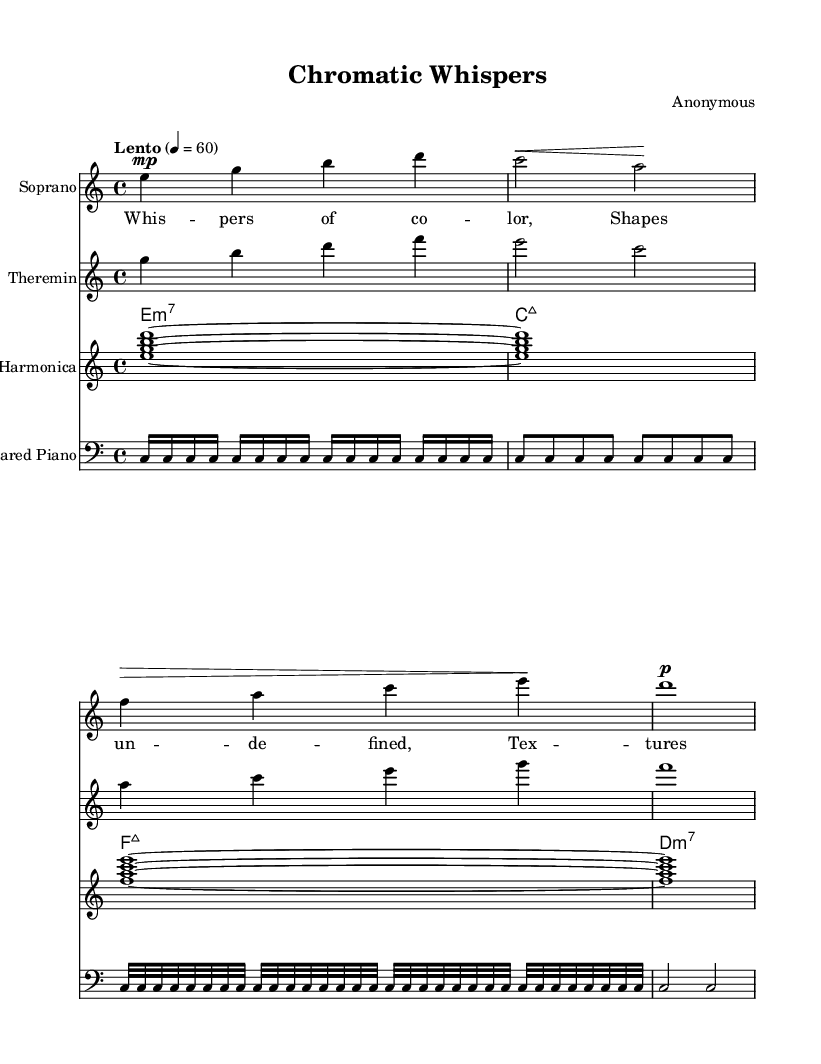What is the time signature of this music? The time signature is indicated at the beginning of the score, where it states "4/4". This means there are four beats in each measure.
Answer: 4/4 What is the tempo marking for this piece? The tempo marking is found in the global section, stating "Lento" with a metronome indication of 60 beats per minute. "Lento" describes a slow pace for the music.
Answer: Lento, 60 How many measures are in the soprano voice part? By examining the soprano voice part, there are a total of four measures indicated by the use of bar lines.
Answer: 4 Which instruments are used in this opera? The score specifies several instruments: Soprano, Theremin, Glass Harmonica, and Prepared Piano. Each is listed as a separate staff, indicating their presence.
Answer: Soprano, Theremin, Glass Harmonica, Prepared Piano What musical form is primarily used in this opera? The piece appears to utilize a verse structure based on the lyrics provided. Each line of the verse corresponds to the music, which suggests a strophic form is being employed.
Answer: Strophic What is the first note played in the prepared piano part? The prepared piano part starts with "c," which is the first note in the sequence of notes provided for this instrument.
Answer: c How many different chord types are represented in the synthesizer chords? There are three types of chords indicated in the synthesizer chords: minor 7th, major 7th, and minor 7th again. This shows diversity in the harmonies used.
Answer: 3 